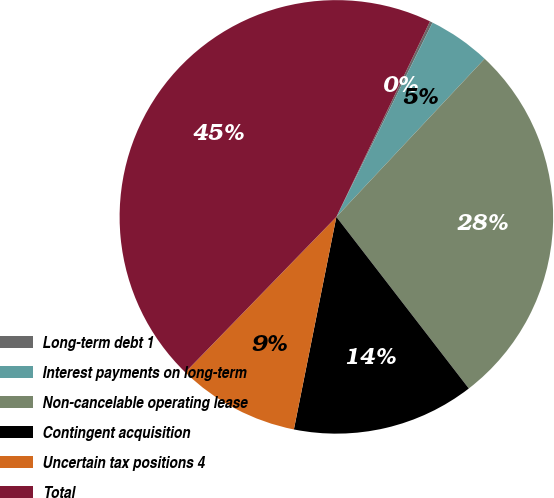Convert chart to OTSL. <chart><loc_0><loc_0><loc_500><loc_500><pie_chart><fcel>Long-term debt 1<fcel>Interest payments on long-term<fcel>Non-cancelable operating lease<fcel>Contingent acquisition<fcel>Uncertain tax positions 4<fcel>Total<nl><fcel>0.21%<fcel>4.67%<fcel>27.55%<fcel>13.6%<fcel>9.13%<fcel>44.83%<nl></chart> 